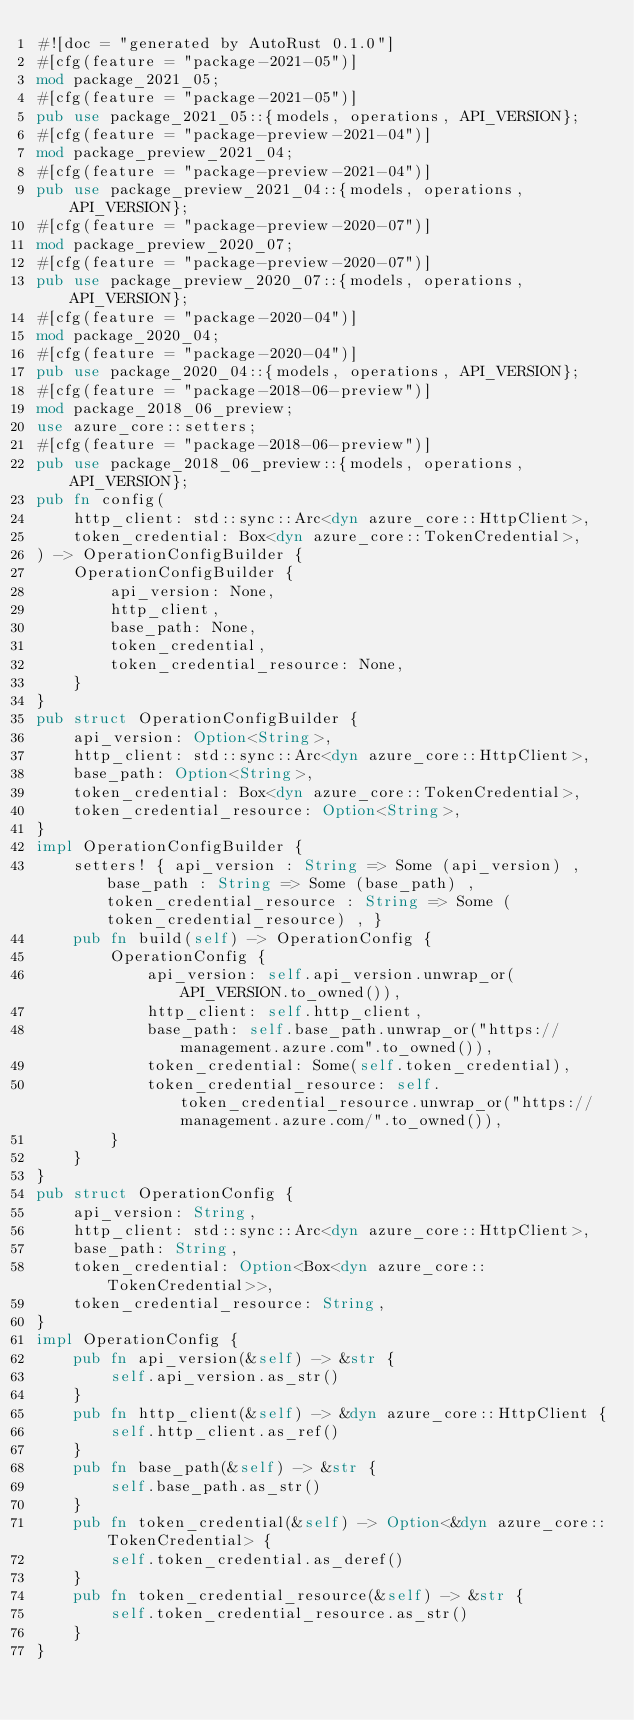Convert code to text. <code><loc_0><loc_0><loc_500><loc_500><_Rust_>#![doc = "generated by AutoRust 0.1.0"]
#[cfg(feature = "package-2021-05")]
mod package_2021_05;
#[cfg(feature = "package-2021-05")]
pub use package_2021_05::{models, operations, API_VERSION};
#[cfg(feature = "package-preview-2021-04")]
mod package_preview_2021_04;
#[cfg(feature = "package-preview-2021-04")]
pub use package_preview_2021_04::{models, operations, API_VERSION};
#[cfg(feature = "package-preview-2020-07")]
mod package_preview_2020_07;
#[cfg(feature = "package-preview-2020-07")]
pub use package_preview_2020_07::{models, operations, API_VERSION};
#[cfg(feature = "package-2020-04")]
mod package_2020_04;
#[cfg(feature = "package-2020-04")]
pub use package_2020_04::{models, operations, API_VERSION};
#[cfg(feature = "package-2018-06-preview")]
mod package_2018_06_preview;
use azure_core::setters;
#[cfg(feature = "package-2018-06-preview")]
pub use package_2018_06_preview::{models, operations, API_VERSION};
pub fn config(
    http_client: std::sync::Arc<dyn azure_core::HttpClient>,
    token_credential: Box<dyn azure_core::TokenCredential>,
) -> OperationConfigBuilder {
    OperationConfigBuilder {
        api_version: None,
        http_client,
        base_path: None,
        token_credential,
        token_credential_resource: None,
    }
}
pub struct OperationConfigBuilder {
    api_version: Option<String>,
    http_client: std::sync::Arc<dyn azure_core::HttpClient>,
    base_path: Option<String>,
    token_credential: Box<dyn azure_core::TokenCredential>,
    token_credential_resource: Option<String>,
}
impl OperationConfigBuilder {
    setters! { api_version : String => Some (api_version) , base_path : String => Some (base_path) , token_credential_resource : String => Some (token_credential_resource) , }
    pub fn build(self) -> OperationConfig {
        OperationConfig {
            api_version: self.api_version.unwrap_or(API_VERSION.to_owned()),
            http_client: self.http_client,
            base_path: self.base_path.unwrap_or("https://management.azure.com".to_owned()),
            token_credential: Some(self.token_credential),
            token_credential_resource: self.token_credential_resource.unwrap_or("https://management.azure.com/".to_owned()),
        }
    }
}
pub struct OperationConfig {
    api_version: String,
    http_client: std::sync::Arc<dyn azure_core::HttpClient>,
    base_path: String,
    token_credential: Option<Box<dyn azure_core::TokenCredential>>,
    token_credential_resource: String,
}
impl OperationConfig {
    pub fn api_version(&self) -> &str {
        self.api_version.as_str()
    }
    pub fn http_client(&self) -> &dyn azure_core::HttpClient {
        self.http_client.as_ref()
    }
    pub fn base_path(&self) -> &str {
        self.base_path.as_str()
    }
    pub fn token_credential(&self) -> Option<&dyn azure_core::TokenCredential> {
        self.token_credential.as_deref()
    }
    pub fn token_credential_resource(&self) -> &str {
        self.token_credential_resource.as_str()
    }
}
</code> 